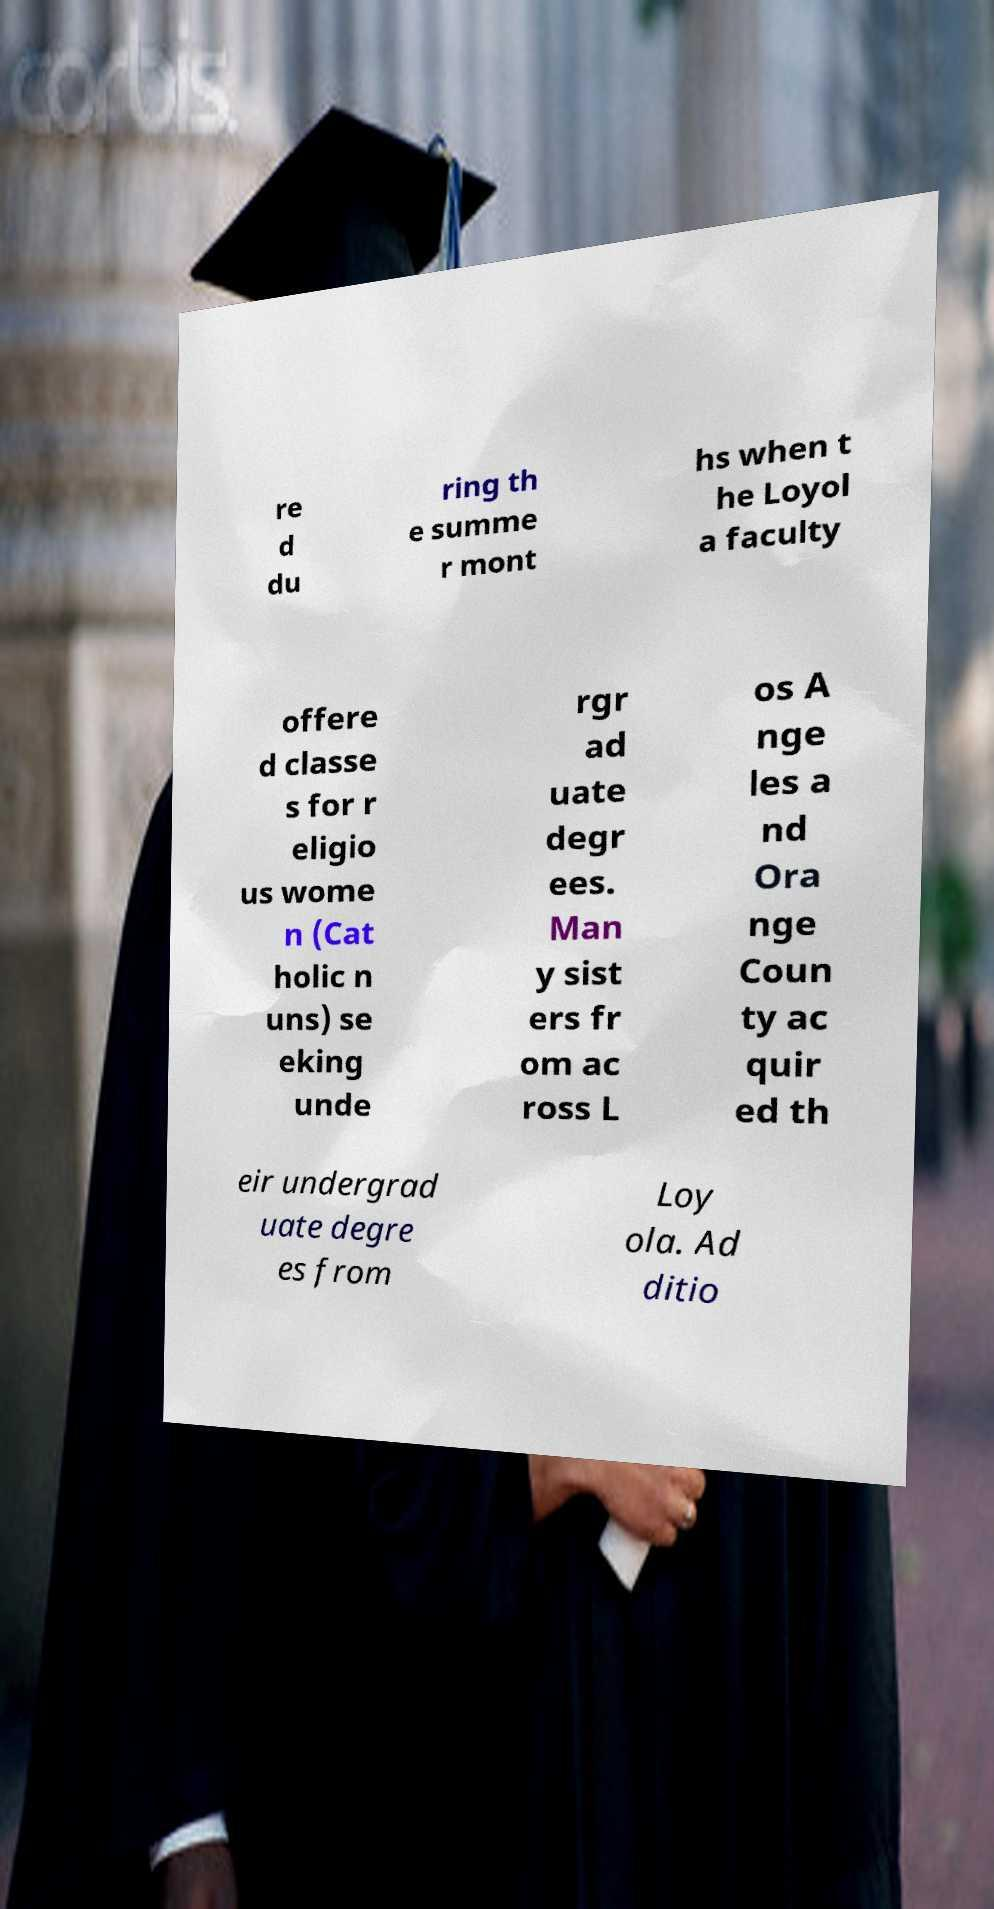Can you accurately transcribe the text from the provided image for me? re d du ring th e summe r mont hs when t he Loyol a faculty offere d classe s for r eligio us wome n (Cat holic n uns) se eking unde rgr ad uate degr ees. Man y sist ers fr om ac ross L os A nge les a nd Ora nge Coun ty ac quir ed th eir undergrad uate degre es from Loy ola. Ad ditio 